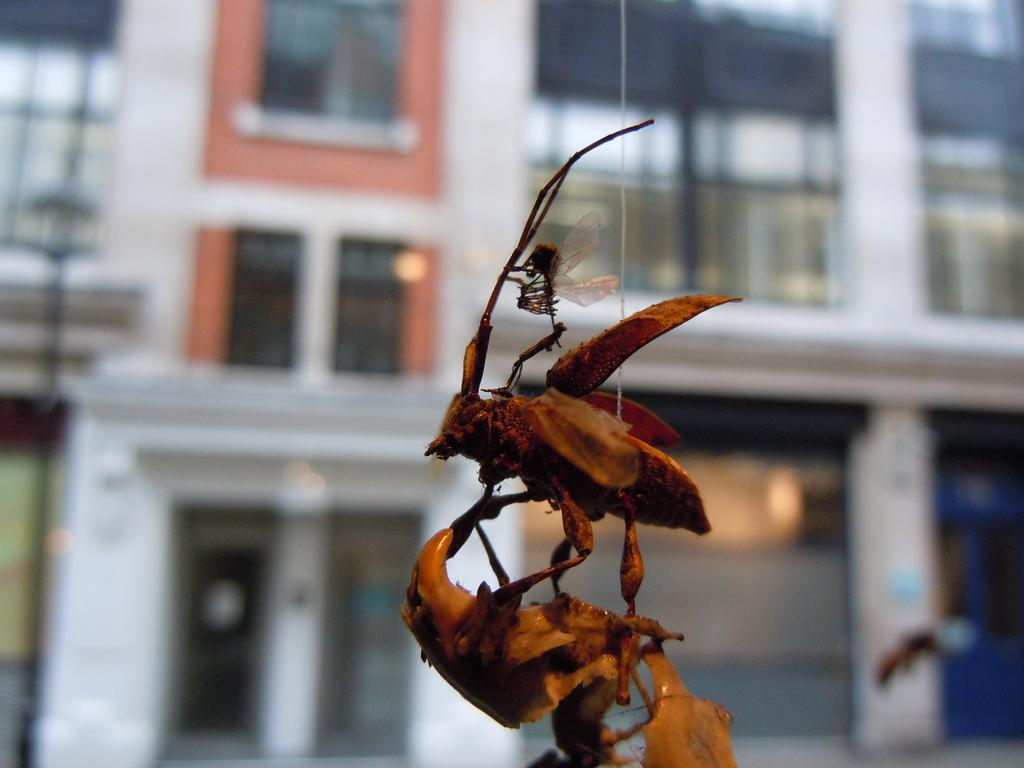What type of creatures are present in the image? There are insects in the image. How are the insects arranged in the image? The insects are stacked one upon the other. What can be seen in the background of the image? There is a hand and a building visible in the background. What type of bike is being ridden by the insects in the image? There is no bike present in the image; it features insects stacked one upon the other. How does the hand in the background of the image feel about the insects? The image does not provide any information about the feelings or emotions of the hand or any other elements in the image. 